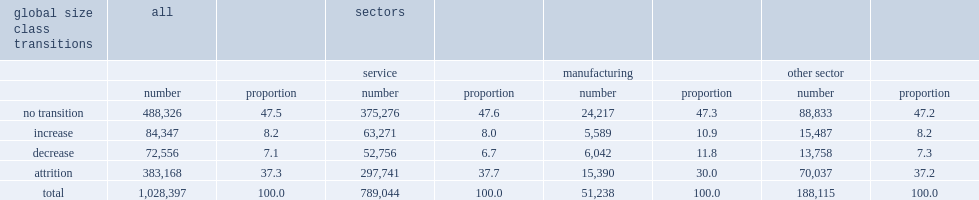How many percent of all enterprises in 2008 have kept their 2008 size. 47.5. How many percent of enterprises in 2008 have increased their size in 2014? 8.2. How many percent of enterprises of 2008 in 2004 have decreased their size? 7.1. How many percent of enterprises of 2008 in 2004 went to "attrition". 37.3. Which sector has the lowest proportion of enterprises that went to "attrition"? Manufacturing. How many percent of 2008 enterprises are in manufacturing sector? 0.049823. 